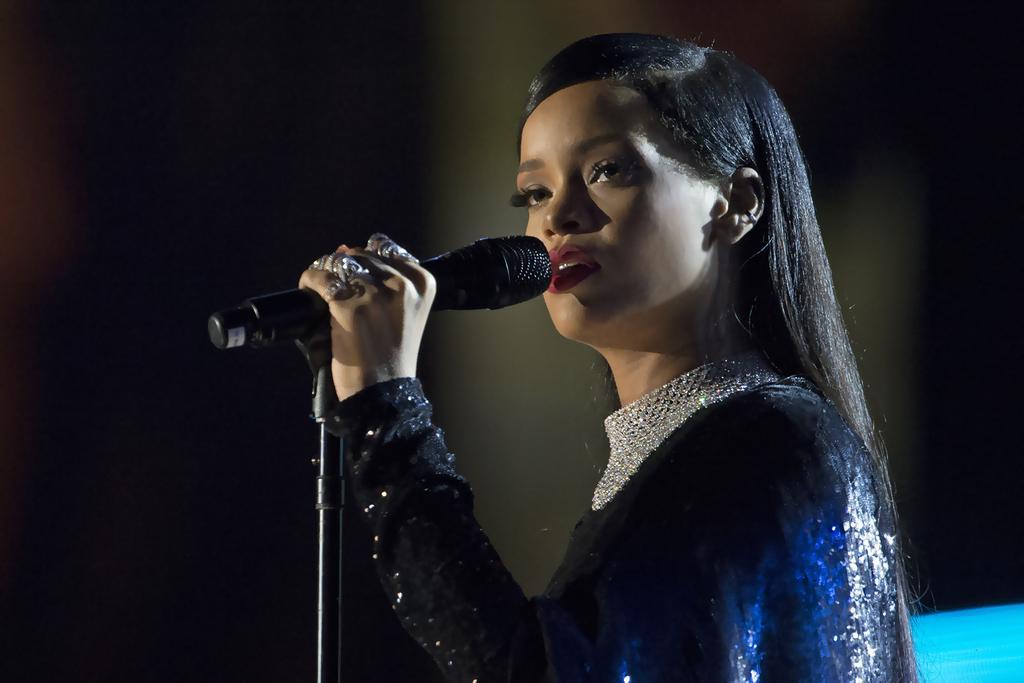Could you give a brief overview of what you see in this image? In this picture I can see a woman holding a mic. I can see the darkness in the background. 